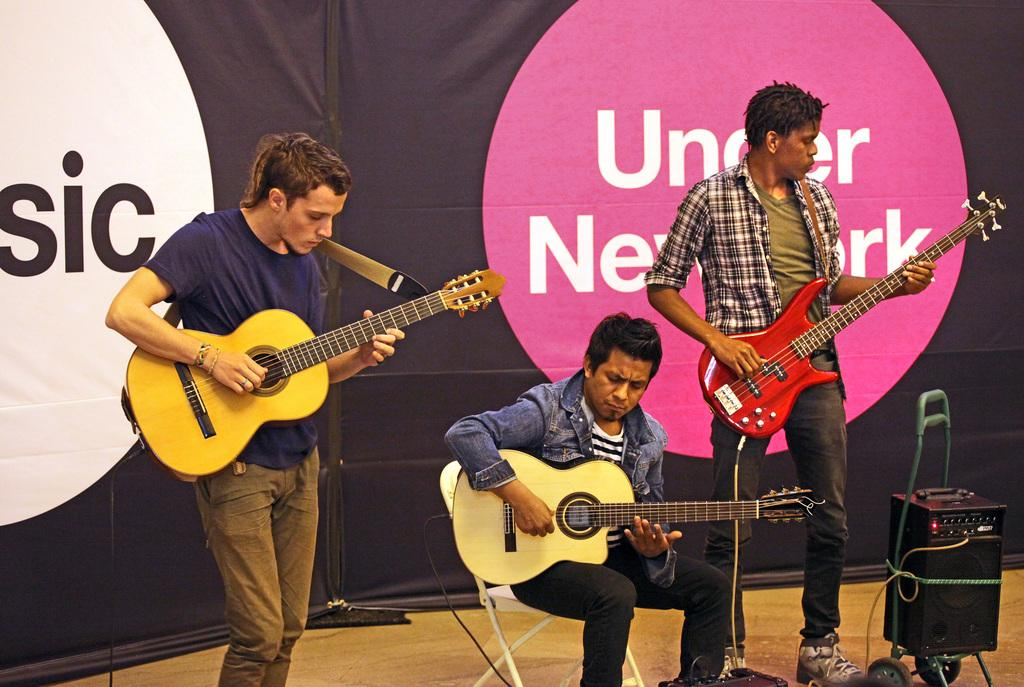How many people are in the image? There are three persons in the image. What are two of the persons doing in the image? Two of the persons are standing and playing guitar. What is the third person doing in the image? The third person is sitting and playing guitar. What can be seen in the background of the image? There is a banner in the background of the image. What time of day is it in the image, and is there any snow visible? The time of day cannot be determined from the image, and there is no snow visible. 